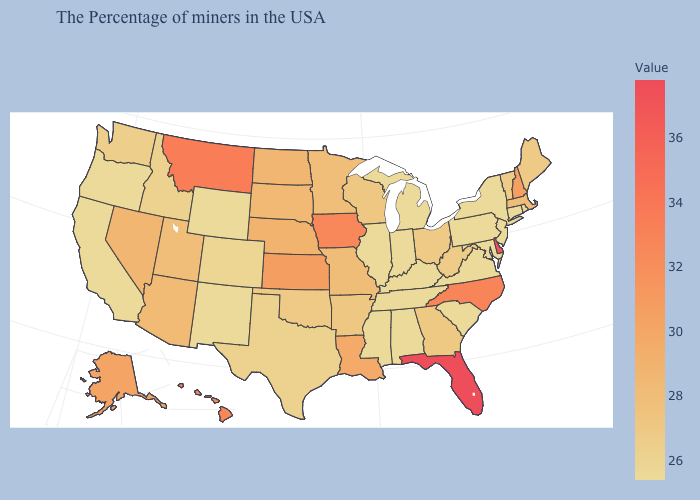Among the states that border Louisiana , does Arkansas have the highest value?
Keep it brief. Yes. Does California have the lowest value in the USA?
Write a very short answer. Yes. Which states have the lowest value in the MidWest?
Write a very short answer. Michigan, Indiana, Illinois. Among the states that border Wisconsin , which have the highest value?
Short answer required. Iowa. 